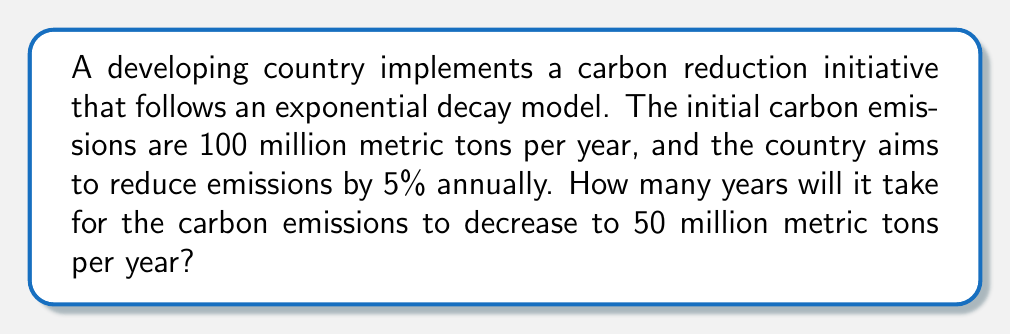Help me with this question. Let's approach this step-by-step:

1) The exponential decay formula is:
   $$A(t) = A_0 \cdot (1-r)^t$$
   where:
   $A(t)$ is the amount at time $t$
   $A_0$ is the initial amount
   $r$ is the decay rate (as a decimal)
   $t$ is the time

2) We know:
   $A_0 = 100$ million metric tons
   $r = 0.05$ (5% annually)
   $A(t) = 50$ million metric tons (target)

3) Let's plug these into our formula:
   $$50 = 100 \cdot (1-0.05)^t$$

4) Simplify:
   $$50 = 100 \cdot (0.95)^t$$

5) Divide both sides by 100:
   $$0.5 = (0.95)^t$$

6) Take the natural log of both sides:
   $$\ln(0.5) = \ln((0.95)^t)$$

7) Use the logarithm property $\ln(a^b) = b\ln(a)$:
   $$\ln(0.5) = t \cdot \ln(0.95)$$

8) Solve for $t$:
   $$t = \frac{\ln(0.5)}{\ln(0.95)} \approx 13.51$$

9) Since we're dealing with whole years, we round up to 14 years.
Answer: 14 years 